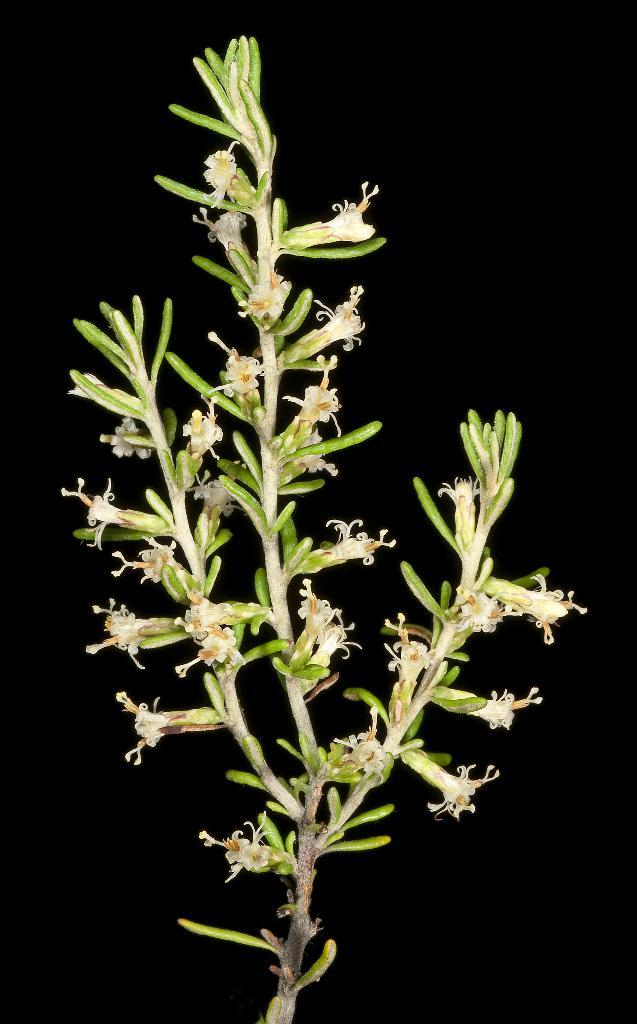What type of living organism can be seen in the image? There is a plant in the image. What specific part of the plant is visible in the image? There are flowers in the image. Is there any blood visible on the flowers in the image? No, there is no blood visible in the image. 